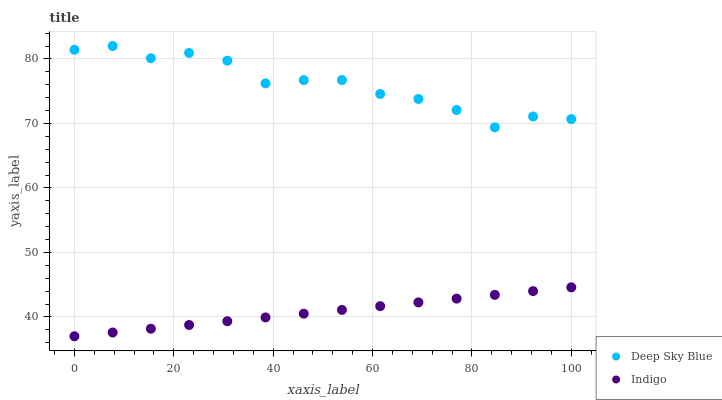Does Indigo have the minimum area under the curve?
Answer yes or no. Yes. Does Deep Sky Blue have the maximum area under the curve?
Answer yes or no. Yes. Does Deep Sky Blue have the minimum area under the curve?
Answer yes or no. No. Is Indigo the smoothest?
Answer yes or no. Yes. Is Deep Sky Blue the roughest?
Answer yes or no. Yes. Is Deep Sky Blue the smoothest?
Answer yes or no. No. Does Indigo have the lowest value?
Answer yes or no. Yes. Does Deep Sky Blue have the lowest value?
Answer yes or no. No. Does Deep Sky Blue have the highest value?
Answer yes or no. Yes. Is Indigo less than Deep Sky Blue?
Answer yes or no. Yes. Is Deep Sky Blue greater than Indigo?
Answer yes or no. Yes. Does Indigo intersect Deep Sky Blue?
Answer yes or no. No. 